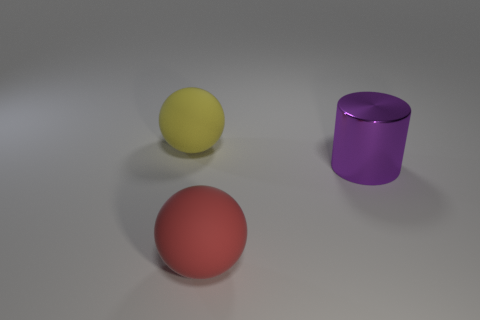There is a thing that is in front of the big purple cylinder; what material is it?
Offer a very short reply. Rubber. Are there any big yellow matte things that have the same shape as the big red matte thing?
Your answer should be compact. Yes. What number of other things are the same shape as the big purple thing?
Make the answer very short. 0. Is the shape of the purple metal object the same as the large matte thing that is in front of the yellow sphere?
Provide a succinct answer. No. Is there anything else that has the same material as the cylinder?
Offer a terse response. No. There is another large object that is the same shape as the large yellow matte thing; what material is it?
Offer a very short reply. Rubber. How many tiny things are either matte cylinders or yellow spheres?
Make the answer very short. 0. Are there fewer big yellow matte balls on the left side of the yellow matte sphere than shiny objects that are in front of the large purple metallic cylinder?
Offer a very short reply. No. What number of objects are either yellow spheres or cyan matte balls?
Provide a succinct answer. 1. There is a large purple thing; how many big red spheres are to the right of it?
Make the answer very short. 0. 